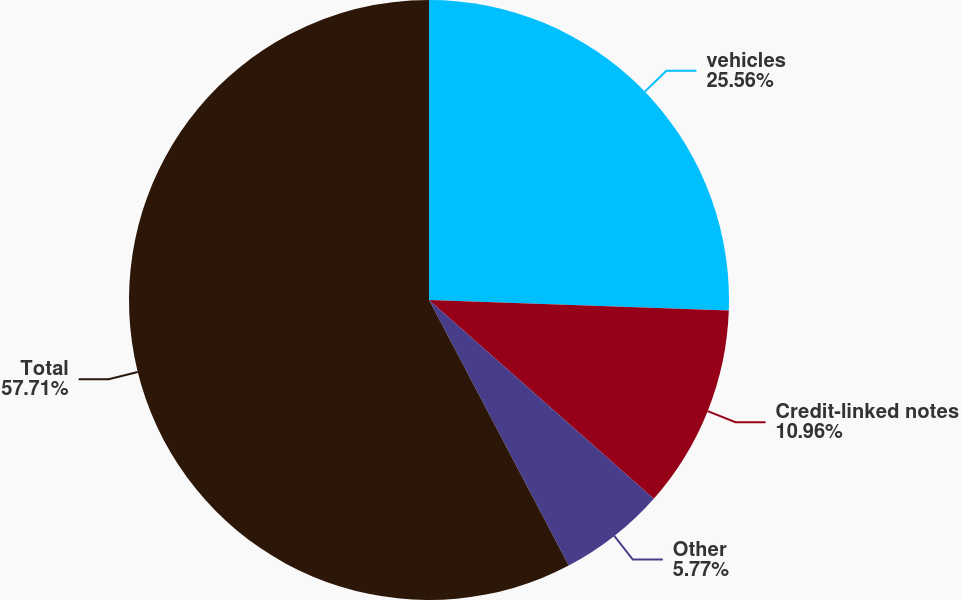Convert chart to OTSL. <chart><loc_0><loc_0><loc_500><loc_500><pie_chart><fcel>vehicles<fcel>Credit-linked notes<fcel>Other<fcel>Total<nl><fcel>25.56%<fcel>10.96%<fcel>5.77%<fcel>57.71%<nl></chart> 